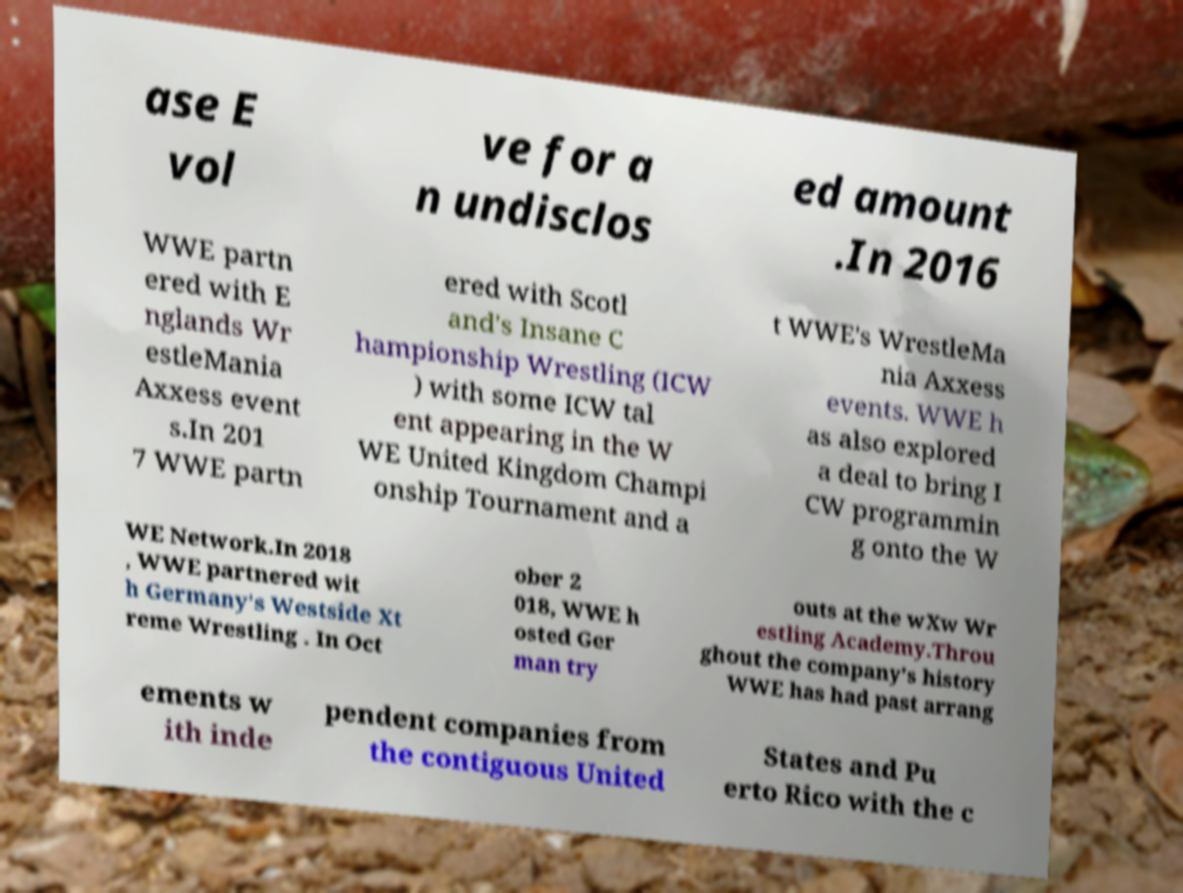I need the written content from this picture converted into text. Can you do that? ase E vol ve for a n undisclos ed amount .In 2016 WWE partn ered with E nglands Wr estleMania Axxess event s.In 201 7 WWE partn ered with Scotl and's Insane C hampionship Wrestling (ICW ) with some ICW tal ent appearing in the W WE United Kingdom Champi onship Tournament and a t WWE's WrestleMa nia Axxess events. WWE h as also explored a deal to bring I CW programmin g onto the W WE Network.In 2018 , WWE partnered wit h Germany's Westside Xt reme Wrestling . In Oct ober 2 018, WWE h osted Ger man try outs at the wXw Wr estling Academy.Throu ghout the company's history WWE has had past arrang ements w ith inde pendent companies from the contiguous United States and Pu erto Rico with the c 